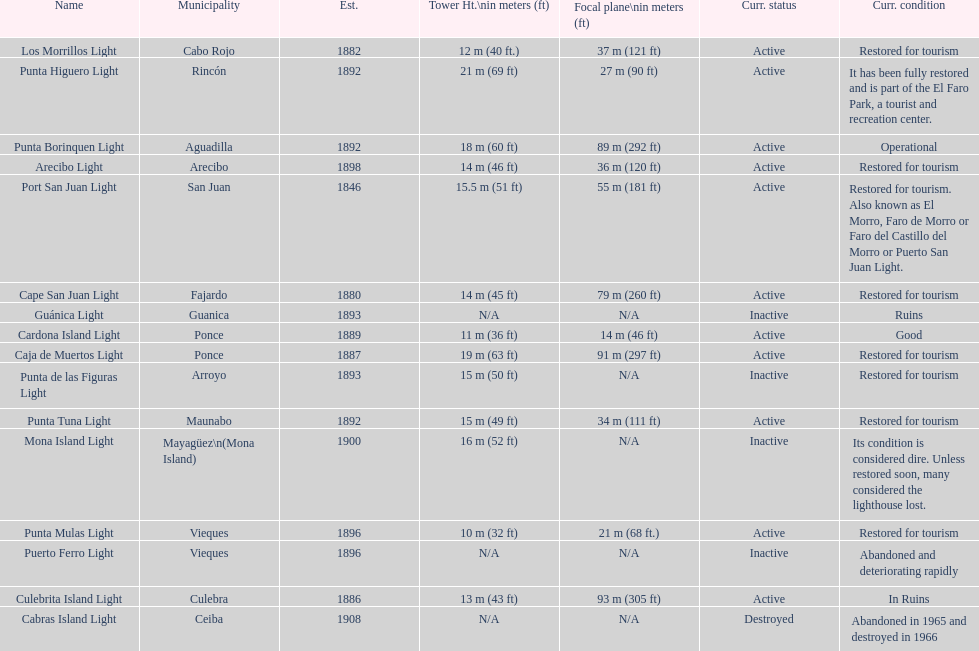Cardona island light and caja de muertos light are both located in what municipality? Ponce. 